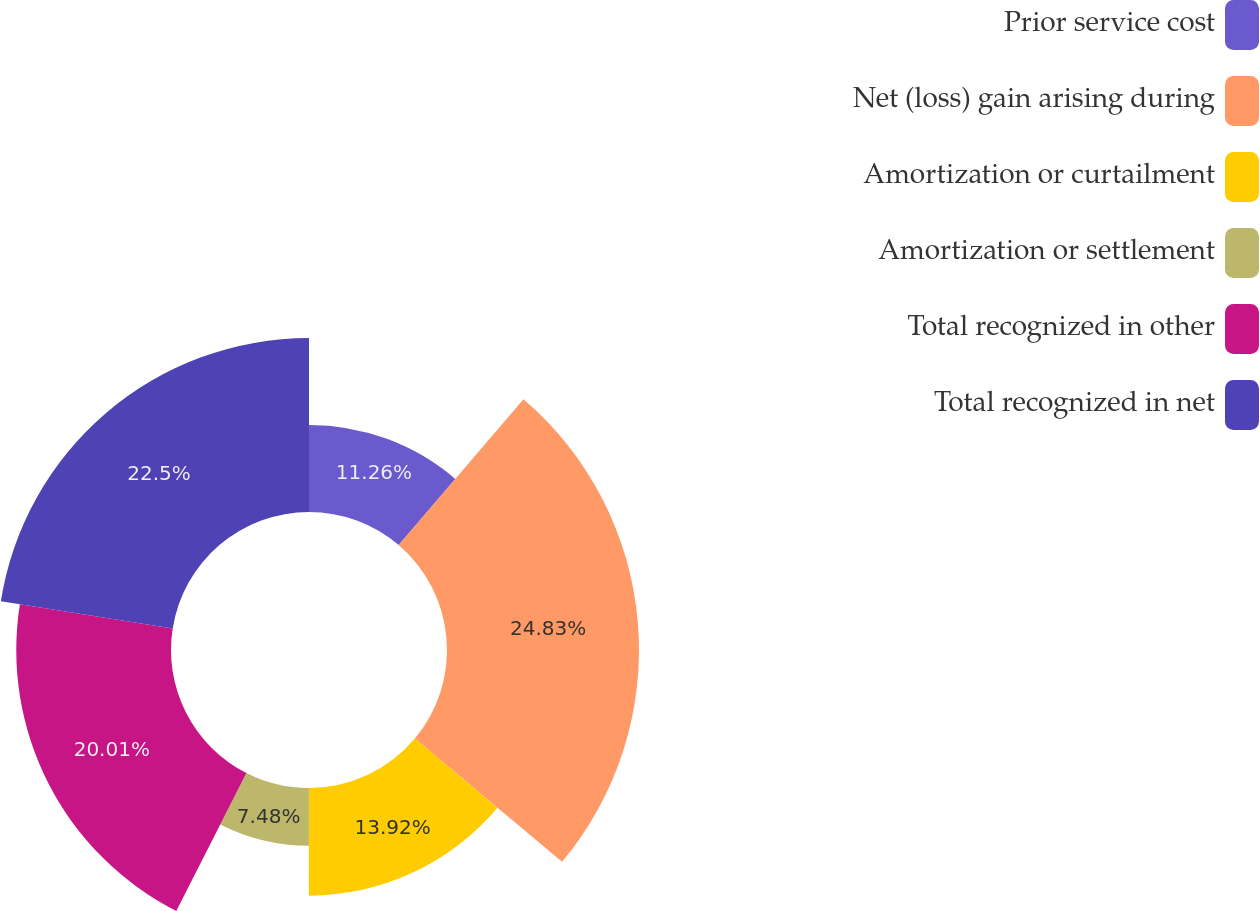Convert chart. <chart><loc_0><loc_0><loc_500><loc_500><pie_chart><fcel>Prior service cost<fcel>Net (loss) gain arising during<fcel>Amortization or curtailment<fcel>Amortization or settlement<fcel>Total recognized in other<fcel>Total recognized in net<nl><fcel>11.26%<fcel>24.83%<fcel>13.92%<fcel>7.48%<fcel>20.01%<fcel>22.5%<nl></chart> 